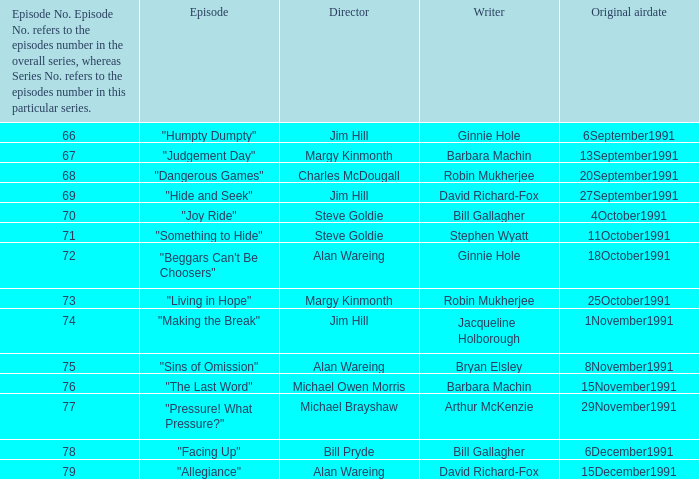Name the original airdate for robin mukherjee and margy kinmonth 25October1991. 